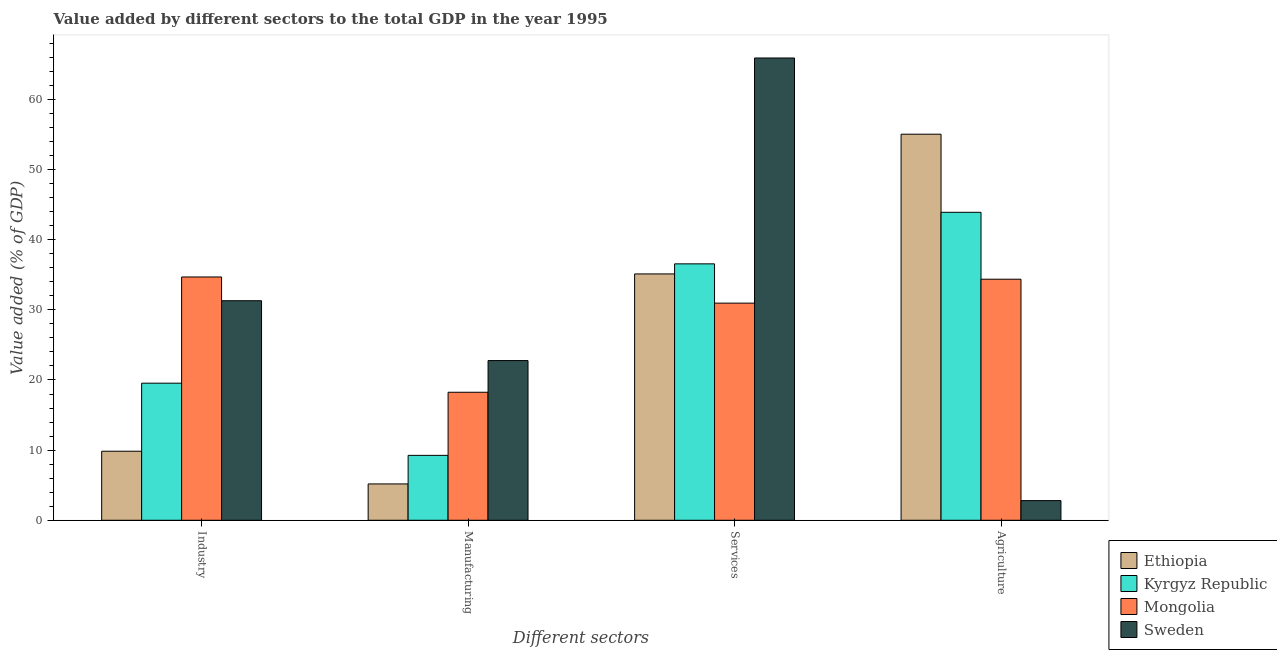How many groups of bars are there?
Provide a succinct answer. 4. Are the number of bars on each tick of the X-axis equal?
Make the answer very short. Yes. How many bars are there on the 4th tick from the left?
Give a very brief answer. 4. What is the label of the 2nd group of bars from the left?
Provide a short and direct response. Manufacturing. What is the value added by manufacturing sector in Sweden?
Offer a very short reply. 22.77. Across all countries, what is the maximum value added by services sector?
Ensure brevity in your answer.  65.9. Across all countries, what is the minimum value added by services sector?
Provide a short and direct response. 30.95. In which country was the value added by services sector maximum?
Offer a terse response. Sweden. In which country was the value added by industrial sector minimum?
Give a very brief answer. Ethiopia. What is the total value added by manufacturing sector in the graph?
Your answer should be very brief. 55.44. What is the difference between the value added by industrial sector in Mongolia and that in Kyrgyz Republic?
Make the answer very short. 15.14. What is the difference between the value added by agricultural sector in Sweden and the value added by manufacturing sector in Mongolia?
Your answer should be compact. -15.45. What is the average value added by services sector per country?
Offer a terse response. 42.13. What is the difference between the value added by industrial sector and value added by services sector in Sweden?
Provide a succinct answer. -34.6. In how many countries, is the value added by industrial sector greater than 30 %?
Your answer should be very brief. 2. What is the ratio of the value added by services sector in Kyrgyz Republic to that in Sweden?
Ensure brevity in your answer.  0.55. What is the difference between the highest and the second highest value added by services sector?
Offer a terse response. 29.35. What is the difference between the highest and the lowest value added by industrial sector?
Keep it short and to the point. 24.84. Is the sum of the value added by manufacturing sector in Kyrgyz Republic and Mongolia greater than the maximum value added by services sector across all countries?
Offer a terse response. No. Is it the case that in every country, the sum of the value added by industrial sector and value added by agricultural sector is greater than the sum of value added by services sector and value added by manufacturing sector?
Your answer should be very brief. No. What does the 2nd bar from the left in Agriculture represents?
Keep it short and to the point. Kyrgyz Republic. What does the 4th bar from the right in Services represents?
Provide a succinct answer. Ethiopia. How many bars are there?
Offer a terse response. 16. Are all the bars in the graph horizontal?
Your answer should be very brief. No. How many countries are there in the graph?
Provide a short and direct response. 4. Does the graph contain any zero values?
Your answer should be compact. No. Does the graph contain grids?
Offer a very short reply. No. Where does the legend appear in the graph?
Your response must be concise. Bottom right. How many legend labels are there?
Ensure brevity in your answer.  4. What is the title of the graph?
Keep it short and to the point. Value added by different sectors to the total GDP in the year 1995. What is the label or title of the X-axis?
Offer a terse response. Different sectors. What is the label or title of the Y-axis?
Ensure brevity in your answer.  Value added (% of GDP). What is the Value added (% of GDP) of Ethiopia in Industry?
Provide a succinct answer. 9.84. What is the Value added (% of GDP) in Kyrgyz Republic in Industry?
Keep it short and to the point. 19.54. What is the Value added (% of GDP) of Mongolia in Industry?
Provide a succinct answer. 34.68. What is the Value added (% of GDP) in Sweden in Industry?
Provide a short and direct response. 31.3. What is the Value added (% of GDP) of Ethiopia in Manufacturing?
Your answer should be compact. 5.18. What is the Value added (% of GDP) of Kyrgyz Republic in Manufacturing?
Provide a succinct answer. 9.25. What is the Value added (% of GDP) of Mongolia in Manufacturing?
Offer a terse response. 18.25. What is the Value added (% of GDP) of Sweden in Manufacturing?
Keep it short and to the point. 22.77. What is the Value added (% of GDP) of Ethiopia in Services?
Keep it short and to the point. 35.12. What is the Value added (% of GDP) in Kyrgyz Republic in Services?
Your answer should be compact. 36.55. What is the Value added (% of GDP) of Mongolia in Services?
Make the answer very short. 30.95. What is the Value added (% of GDP) of Sweden in Services?
Give a very brief answer. 65.9. What is the Value added (% of GDP) of Ethiopia in Agriculture?
Your answer should be very brief. 55.04. What is the Value added (% of GDP) in Kyrgyz Republic in Agriculture?
Provide a short and direct response. 43.9. What is the Value added (% of GDP) in Mongolia in Agriculture?
Give a very brief answer. 34.36. What is the Value added (% of GDP) in Sweden in Agriculture?
Your answer should be compact. 2.8. Across all Different sectors, what is the maximum Value added (% of GDP) of Ethiopia?
Your response must be concise. 55.04. Across all Different sectors, what is the maximum Value added (% of GDP) in Kyrgyz Republic?
Ensure brevity in your answer.  43.9. Across all Different sectors, what is the maximum Value added (% of GDP) of Mongolia?
Ensure brevity in your answer.  34.68. Across all Different sectors, what is the maximum Value added (% of GDP) in Sweden?
Ensure brevity in your answer.  65.9. Across all Different sectors, what is the minimum Value added (% of GDP) of Ethiopia?
Your response must be concise. 5.18. Across all Different sectors, what is the minimum Value added (% of GDP) of Kyrgyz Republic?
Provide a succinct answer. 9.25. Across all Different sectors, what is the minimum Value added (% of GDP) of Mongolia?
Your answer should be compact. 18.25. Across all Different sectors, what is the minimum Value added (% of GDP) of Sweden?
Give a very brief answer. 2.8. What is the total Value added (% of GDP) of Ethiopia in the graph?
Make the answer very short. 105.18. What is the total Value added (% of GDP) in Kyrgyz Republic in the graph?
Make the answer very short. 109.25. What is the total Value added (% of GDP) in Mongolia in the graph?
Provide a short and direct response. 118.25. What is the total Value added (% of GDP) in Sweden in the graph?
Keep it short and to the point. 122.77. What is the difference between the Value added (% of GDP) in Ethiopia in Industry and that in Manufacturing?
Your response must be concise. 4.66. What is the difference between the Value added (% of GDP) of Kyrgyz Republic in Industry and that in Manufacturing?
Give a very brief answer. 10.29. What is the difference between the Value added (% of GDP) of Mongolia in Industry and that in Manufacturing?
Keep it short and to the point. 16.43. What is the difference between the Value added (% of GDP) in Sweden in Industry and that in Manufacturing?
Provide a short and direct response. 8.53. What is the difference between the Value added (% of GDP) of Ethiopia in Industry and that in Services?
Give a very brief answer. -25.28. What is the difference between the Value added (% of GDP) of Kyrgyz Republic in Industry and that in Services?
Your response must be concise. -17.01. What is the difference between the Value added (% of GDP) in Mongolia in Industry and that in Services?
Your answer should be very brief. 3.73. What is the difference between the Value added (% of GDP) in Sweden in Industry and that in Services?
Provide a short and direct response. -34.6. What is the difference between the Value added (% of GDP) of Ethiopia in Industry and that in Agriculture?
Provide a short and direct response. -45.2. What is the difference between the Value added (% of GDP) in Kyrgyz Republic in Industry and that in Agriculture?
Ensure brevity in your answer.  -24.36. What is the difference between the Value added (% of GDP) in Mongolia in Industry and that in Agriculture?
Keep it short and to the point. 0.32. What is the difference between the Value added (% of GDP) in Sweden in Industry and that in Agriculture?
Your answer should be compact. 28.49. What is the difference between the Value added (% of GDP) of Ethiopia in Manufacturing and that in Services?
Give a very brief answer. -29.94. What is the difference between the Value added (% of GDP) in Kyrgyz Republic in Manufacturing and that in Services?
Ensure brevity in your answer.  -27.3. What is the difference between the Value added (% of GDP) of Mongolia in Manufacturing and that in Services?
Offer a very short reply. -12.71. What is the difference between the Value added (% of GDP) in Sweden in Manufacturing and that in Services?
Your answer should be compact. -43.14. What is the difference between the Value added (% of GDP) in Ethiopia in Manufacturing and that in Agriculture?
Your response must be concise. -49.86. What is the difference between the Value added (% of GDP) in Kyrgyz Republic in Manufacturing and that in Agriculture?
Offer a terse response. -34.65. What is the difference between the Value added (% of GDP) of Mongolia in Manufacturing and that in Agriculture?
Provide a short and direct response. -16.12. What is the difference between the Value added (% of GDP) of Sweden in Manufacturing and that in Agriculture?
Give a very brief answer. 19.96. What is the difference between the Value added (% of GDP) of Ethiopia in Services and that in Agriculture?
Make the answer very short. -19.92. What is the difference between the Value added (% of GDP) in Kyrgyz Republic in Services and that in Agriculture?
Ensure brevity in your answer.  -7.35. What is the difference between the Value added (% of GDP) in Mongolia in Services and that in Agriculture?
Ensure brevity in your answer.  -3.41. What is the difference between the Value added (% of GDP) in Sweden in Services and that in Agriculture?
Your response must be concise. 63.1. What is the difference between the Value added (% of GDP) in Ethiopia in Industry and the Value added (% of GDP) in Kyrgyz Republic in Manufacturing?
Your answer should be compact. 0.59. What is the difference between the Value added (% of GDP) in Ethiopia in Industry and the Value added (% of GDP) in Mongolia in Manufacturing?
Make the answer very short. -8.41. What is the difference between the Value added (% of GDP) of Ethiopia in Industry and the Value added (% of GDP) of Sweden in Manufacturing?
Provide a short and direct response. -12.92. What is the difference between the Value added (% of GDP) of Kyrgyz Republic in Industry and the Value added (% of GDP) of Mongolia in Manufacturing?
Your answer should be compact. 1.29. What is the difference between the Value added (% of GDP) of Kyrgyz Republic in Industry and the Value added (% of GDP) of Sweden in Manufacturing?
Make the answer very short. -3.22. What is the difference between the Value added (% of GDP) of Mongolia in Industry and the Value added (% of GDP) of Sweden in Manufacturing?
Provide a succinct answer. 11.92. What is the difference between the Value added (% of GDP) of Ethiopia in Industry and the Value added (% of GDP) of Kyrgyz Republic in Services?
Your response must be concise. -26.71. What is the difference between the Value added (% of GDP) in Ethiopia in Industry and the Value added (% of GDP) in Mongolia in Services?
Your answer should be very brief. -21.11. What is the difference between the Value added (% of GDP) in Ethiopia in Industry and the Value added (% of GDP) in Sweden in Services?
Your answer should be very brief. -56.06. What is the difference between the Value added (% of GDP) of Kyrgyz Republic in Industry and the Value added (% of GDP) of Mongolia in Services?
Make the answer very short. -11.41. What is the difference between the Value added (% of GDP) of Kyrgyz Republic in Industry and the Value added (% of GDP) of Sweden in Services?
Your response must be concise. -46.36. What is the difference between the Value added (% of GDP) of Mongolia in Industry and the Value added (% of GDP) of Sweden in Services?
Offer a very short reply. -31.22. What is the difference between the Value added (% of GDP) in Ethiopia in Industry and the Value added (% of GDP) in Kyrgyz Republic in Agriculture?
Provide a succinct answer. -34.06. What is the difference between the Value added (% of GDP) in Ethiopia in Industry and the Value added (% of GDP) in Mongolia in Agriculture?
Keep it short and to the point. -24.52. What is the difference between the Value added (% of GDP) of Ethiopia in Industry and the Value added (% of GDP) of Sweden in Agriculture?
Your response must be concise. 7.04. What is the difference between the Value added (% of GDP) of Kyrgyz Republic in Industry and the Value added (% of GDP) of Mongolia in Agriculture?
Provide a succinct answer. -14.82. What is the difference between the Value added (% of GDP) of Kyrgyz Republic in Industry and the Value added (% of GDP) of Sweden in Agriculture?
Provide a succinct answer. 16.74. What is the difference between the Value added (% of GDP) in Mongolia in Industry and the Value added (% of GDP) in Sweden in Agriculture?
Give a very brief answer. 31.88. What is the difference between the Value added (% of GDP) in Ethiopia in Manufacturing and the Value added (% of GDP) in Kyrgyz Republic in Services?
Offer a terse response. -31.38. What is the difference between the Value added (% of GDP) in Ethiopia in Manufacturing and the Value added (% of GDP) in Mongolia in Services?
Your response must be concise. -25.77. What is the difference between the Value added (% of GDP) of Ethiopia in Manufacturing and the Value added (% of GDP) of Sweden in Services?
Offer a terse response. -60.72. What is the difference between the Value added (% of GDP) of Kyrgyz Republic in Manufacturing and the Value added (% of GDP) of Mongolia in Services?
Provide a succinct answer. -21.7. What is the difference between the Value added (% of GDP) of Kyrgyz Republic in Manufacturing and the Value added (% of GDP) of Sweden in Services?
Make the answer very short. -56.65. What is the difference between the Value added (% of GDP) of Mongolia in Manufacturing and the Value added (% of GDP) of Sweden in Services?
Offer a terse response. -47.65. What is the difference between the Value added (% of GDP) in Ethiopia in Manufacturing and the Value added (% of GDP) in Kyrgyz Republic in Agriculture?
Your answer should be compact. -38.72. What is the difference between the Value added (% of GDP) of Ethiopia in Manufacturing and the Value added (% of GDP) of Mongolia in Agriculture?
Keep it short and to the point. -29.18. What is the difference between the Value added (% of GDP) in Ethiopia in Manufacturing and the Value added (% of GDP) in Sweden in Agriculture?
Ensure brevity in your answer.  2.38. What is the difference between the Value added (% of GDP) in Kyrgyz Republic in Manufacturing and the Value added (% of GDP) in Mongolia in Agriculture?
Provide a succinct answer. -25.11. What is the difference between the Value added (% of GDP) of Kyrgyz Republic in Manufacturing and the Value added (% of GDP) of Sweden in Agriculture?
Give a very brief answer. 6.45. What is the difference between the Value added (% of GDP) of Mongolia in Manufacturing and the Value added (% of GDP) of Sweden in Agriculture?
Make the answer very short. 15.45. What is the difference between the Value added (% of GDP) in Ethiopia in Services and the Value added (% of GDP) in Kyrgyz Republic in Agriculture?
Your answer should be very brief. -8.78. What is the difference between the Value added (% of GDP) in Ethiopia in Services and the Value added (% of GDP) in Mongolia in Agriculture?
Give a very brief answer. 0.75. What is the difference between the Value added (% of GDP) of Ethiopia in Services and the Value added (% of GDP) of Sweden in Agriculture?
Your answer should be very brief. 32.32. What is the difference between the Value added (% of GDP) of Kyrgyz Republic in Services and the Value added (% of GDP) of Mongolia in Agriculture?
Make the answer very short. 2.19. What is the difference between the Value added (% of GDP) of Kyrgyz Republic in Services and the Value added (% of GDP) of Sweden in Agriculture?
Ensure brevity in your answer.  33.75. What is the difference between the Value added (% of GDP) of Mongolia in Services and the Value added (% of GDP) of Sweden in Agriculture?
Make the answer very short. 28.15. What is the average Value added (% of GDP) in Ethiopia per Different sectors?
Give a very brief answer. 26.29. What is the average Value added (% of GDP) of Kyrgyz Republic per Different sectors?
Your response must be concise. 27.31. What is the average Value added (% of GDP) in Mongolia per Different sectors?
Provide a succinct answer. 29.56. What is the average Value added (% of GDP) of Sweden per Different sectors?
Your answer should be compact. 30.69. What is the difference between the Value added (% of GDP) in Ethiopia and Value added (% of GDP) in Mongolia in Industry?
Your answer should be compact. -24.84. What is the difference between the Value added (% of GDP) of Ethiopia and Value added (% of GDP) of Sweden in Industry?
Offer a very short reply. -21.45. What is the difference between the Value added (% of GDP) in Kyrgyz Republic and Value added (% of GDP) in Mongolia in Industry?
Your answer should be very brief. -15.14. What is the difference between the Value added (% of GDP) in Kyrgyz Republic and Value added (% of GDP) in Sweden in Industry?
Make the answer very short. -11.75. What is the difference between the Value added (% of GDP) in Mongolia and Value added (% of GDP) in Sweden in Industry?
Your answer should be very brief. 3.39. What is the difference between the Value added (% of GDP) in Ethiopia and Value added (% of GDP) in Kyrgyz Republic in Manufacturing?
Your response must be concise. -4.07. What is the difference between the Value added (% of GDP) in Ethiopia and Value added (% of GDP) in Mongolia in Manufacturing?
Offer a terse response. -13.07. What is the difference between the Value added (% of GDP) of Ethiopia and Value added (% of GDP) of Sweden in Manufacturing?
Offer a very short reply. -17.59. What is the difference between the Value added (% of GDP) in Kyrgyz Republic and Value added (% of GDP) in Mongolia in Manufacturing?
Your response must be concise. -9. What is the difference between the Value added (% of GDP) in Kyrgyz Republic and Value added (% of GDP) in Sweden in Manufacturing?
Your response must be concise. -13.51. What is the difference between the Value added (% of GDP) in Mongolia and Value added (% of GDP) in Sweden in Manufacturing?
Your answer should be very brief. -4.52. What is the difference between the Value added (% of GDP) in Ethiopia and Value added (% of GDP) in Kyrgyz Republic in Services?
Keep it short and to the point. -1.44. What is the difference between the Value added (% of GDP) in Ethiopia and Value added (% of GDP) in Mongolia in Services?
Offer a very short reply. 4.16. What is the difference between the Value added (% of GDP) in Ethiopia and Value added (% of GDP) in Sweden in Services?
Provide a short and direct response. -30.78. What is the difference between the Value added (% of GDP) in Kyrgyz Republic and Value added (% of GDP) in Mongolia in Services?
Make the answer very short. 5.6. What is the difference between the Value added (% of GDP) in Kyrgyz Republic and Value added (% of GDP) in Sweden in Services?
Provide a short and direct response. -29.35. What is the difference between the Value added (% of GDP) in Mongolia and Value added (% of GDP) in Sweden in Services?
Ensure brevity in your answer.  -34.95. What is the difference between the Value added (% of GDP) in Ethiopia and Value added (% of GDP) in Kyrgyz Republic in Agriculture?
Provide a short and direct response. 11.14. What is the difference between the Value added (% of GDP) in Ethiopia and Value added (% of GDP) in Mongolia in Agriculture?
Ensure brevity in your answer.  20.67. What is the difference between the Value added (% of GDP) in Ethiopia and Value added (% of GDP) in Sweden in Agriculture?
Offer a very short reply. 52.24. What is the difference between the Value added (% of GDP) of Kyrgyz Republic and Value added (% of GDP) of Mongolia in Agriculture?
Your answer should be compact. 9.54. What is the difference between the Value added (% of GDP) of Kyrgyz Republic and Value added (% of GDP) of Sweden in Agriculture?
Your answer should be very brief. 41.1. What is the difference between the Value added (% of GDP) in Mongolia and Value added (% of GDP) in Sweden in Agriculture?
Ensure brevity in your answer.  31.56. What is the ratio of the Value added (% of GDP) in Ethiopia in Industry to that in Manufacturing?
Provide a succinct answer. 1.9. What is the ratio of the Value added (% of GDP) in Kyrgyz Republic in Industry to that in Manufacturing?
Offer a terse response. 2.11. What is the ratio of the Value added (% of GDP) in Mongolia in Industry to that in Manufacturing?
Your answer should be compact. 1.9. What is the ratio of the Value added (% of GDP) of Sweden in Industry to that in Manufacturing?
Ensure brevity in your answer.  1.37. What is the ratio of the Value added (% of GDP) in Ethiopia in Industry to that in Services?
Keep it short and to the point. 0.28. What is the ratio of the Value added (% of GDP) of Kyrgyz Republic in Industry to that in Services?
Keep it short and to the point. 0.53. What is the ratio of the Value added (% of GDP) of Mongolia in Industry to that in Services?
Keep it short and to the point. 1.12. What is the ratio of the Value added (% of GDP) of Sweden in Industry to that in Services?
Your response must be concise. 0.47. What is the ratio of the Value added (% of GDP) of Ethiopia in Industry to that in Agriculture?
Give a very brief answer. 0.18. What is the ratio of the Value added (% of GDP) of Kyrgyz Republic in Industry to that in Agriculture?
Make the answer very short. 0.45. What is the ratio of the Value added (% of GDP) of Mongolia in Industry to that in Agriculture?
Make the answer very short. 1.01. What is the ratio of the Value added (% of GDP) of Sweden in Industry to that in Agriculture?
Give a very brief answer. 11.17. What is the ratio of the Value added (% of GDP) of Ethiopia in Manufacturing to that in Services?
Your response must be concise. 0.15. What is the ratio of the Value added (% of GDP) in Kyrgyz Republic in Manufacturing to that in Services?
Keep it short and to the point. 0.25. What is the ratio of the Value added (% of GDP) of Mongolia in Manufacturing to that in Services?
Provide a succinct answer. 0.59. What is the ratio of the Value added (% of GDP) of Sweden in Manufacturing to that in Services?
Keep it short and to the point. 0.35. What is the ratio of the Value added (% of GDP) of Ethiopia in Manufacturing to that in Agriculture?
Offer a terse response. 0.09. What is the ratio of the Value added (% of GDP) in Kyrgyz Republic in Manufacturing to that in Agriculture?
Offer a very short reply. 0.21. What is the ratio of the Value added (% of GDP) in Mongolia in Manufacturing to that in Agriculture?
Give a very brief answer. 0.53. What is the ratio of the Value added (% of GDP) in Sweden in Manufacturing to that in Agriculture?
Provide a succinct answer. 8.13. What is the ratio of the Value added (% of GDP) of Ethiopia in Services to that in Agriculture?
Make the answer very short. 0.64. What is the ratio of the Value added (% of GDP) of Kyrgyz Republic in Services to that in Agriculture?
Your answer should be compact. 0.83. What is the ratio of the Value added (% of GDP) in Mongolia in Services to that in Agriculture?
Offer a terse response. 0.9. What is the ratio of the Value added (% of GDP) of Sweden in Services to that in Agriculture?
Provide a succinct answer. 23.52. What is the difference between the highest and the second highest Value added (% of GDP) of Ethiopia?
Your response must be concise. 19.92. What is the difference between the highest and the second highest Value added (% of GDP) in Kyrgyz Republic?
Make the answer very short. 7.35. What is the difference between the highest and the second highest Value added (% of GDP) in Mongolia?
Provide a succinct answer. 0.32. What is the difference between the highest and the second highest Value added (% of GDP) of Sweden?
Give a very brief answer. 34.6. What is the difference between the highest and the lowest Value added (% of GDP) in Ethiopia?
Your answer should be very brief. 49.86. What is the difference between the highest and the lowest Value added (% of GDP) of Kyrgyz Republic?
Offer a very short reply. 34.65. What is the difference between the highest and the lowest Value added (% of GDP) in Mongolia?
Your answer should be very brief. 16.43. What is the difference between the highest and the lowest Value added (% of GDP) of Sweden?
Your answer should be very brief. 63.1. 